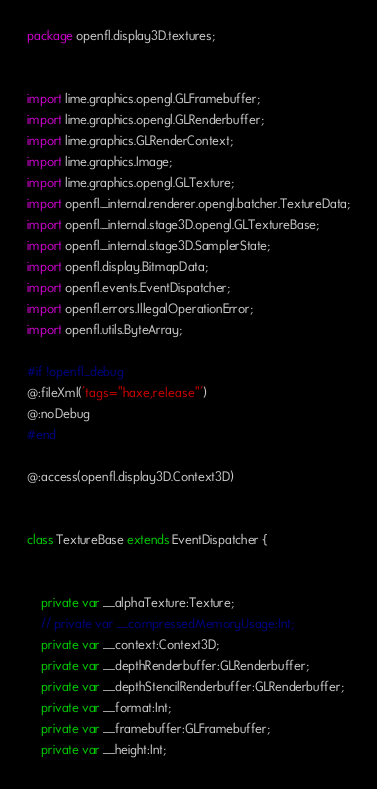Convert code to text. <code><loc_0><loc_0><loc_500><loc_500><_Haxe_>package openfl.display3D.textures;


import lime.graphics.opengl.GLFramebuffer;
import lime.graphics.opengl.GLRenderbuffer;
import lime.graphics.GLRenderContext;
import lime.graphics.Image;
import lime.graphics.opengl.GLTexture;
import openfl._internal.renderer.opengl.batcher.TextureData;
import openfl._internal.stage3D.opengl.GLTextureBase;
import openfl._internal.stage3D.SamplerState;
import openfl.display.BitmapData;
import openfl.events.EventDispatcher;
import openfl.errors.IllegalOperationError;
import openfl.utils.ByteArray;

#if !openfl_debug
@:fileXml('tags="haxe,release"')
@:noDebug
#end

@:access(openfl.display3D.Context3D)


class TextureBase extends EventDispatcher {
	
	
	private var __alphaTexture:Texture;
	// private var __compressedMemoryUsage:Int;
	private var __context:Context3D;
	private var __depthRenderbuffer:GLRenderbuffer;
	private var __depthStencilRenderbuffer:GLRenderbuffer;
	private var __format:Int;
	private var __framebuffer:GLFramebuffer;
	private var __height:Int;</code> 